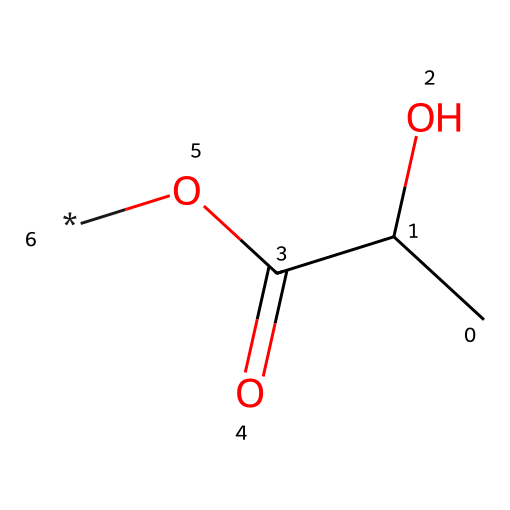What is the total number of carbon atoms in this chemical? Count the carbon atoms represented in the SMILES notation. The "CC" at the beginning indicates two carbon atoms. The notation does not include any additional carbon atoms.
Answer: 2 How many oxygen atoms are present in this chemical? In the provided SMILES, the "O" appears twice: one in the carboxyl group (C(=O)O) and one in the hydroxyl group (C(O)). Therefore, there are two oxygen atoms in total.
Answer: 2 What functional groups are identified in this chemical? The structure contains a hydroxyl group (-OH) and a carboxyl group (-COOH) as indicated by the structure. These groups define its functionality.
Answer: hydroxyl and carboxyl Is this polymer likely to be biodegradable? The presence of natural monomers like those in the structure often implies biodegradability. The specific functional groups, particularly the carboxyl group, suggest that it can break down naturally.
Answer: yes What type of polymer does this chemical represent? Based on its structure and the presence of functional groups, it suggests that this is a type of biodegradable polymer, often used in eco-friendly applications such as seed coatings.
Answer: biodegradable polymer Can this polymer facilitate seed germination? The presence of water-attracting functional groups (like -OH and -COOH) typically indicates that the polymer can retain moisture, which is beneficial for seed germination.
Answer: yes 